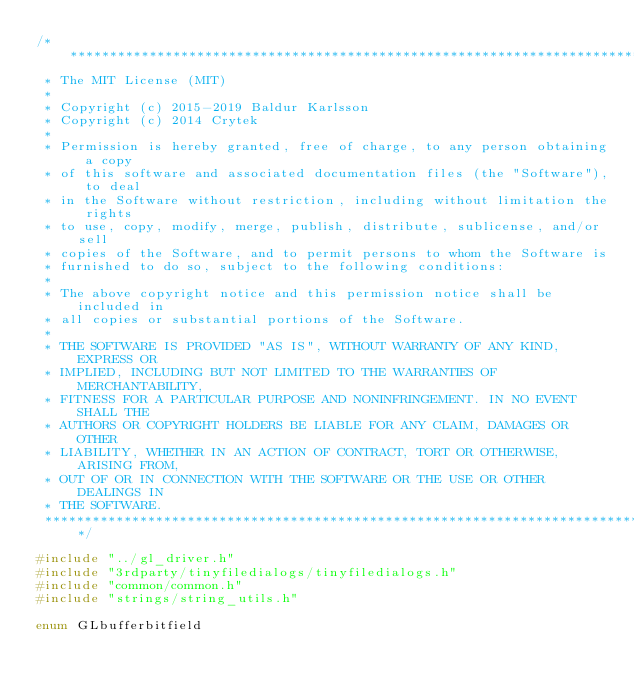Convert code to text. <code><loc_0><loc_0><loc_500><loc_500><_C++_>/******************************************************************************
 * The MIT License (MIT)
 *
 * Copyright (c) 2015-2019 Baldur Karlsson
 * Copyright (c) 2014 Crytek
 *
 * Permission is hereby granted, free of charge, to any person obtaining a copy
 * of this software and associated documentation files (the "Software"), to deal
 * in the Software without restriction, including without limitation the rights
 * to use, copy, modify, merge, publish, distribute, sublicense, and/or sell
 * copies of the Software, and to permit persons to whom the Software is
 * furnished to do so, subject to the following conditions:
 *
 * The above copyright notice and this permission notice shall be included in
 * all copies or substantial portions of the Software.
 *
 * THE SOFTWARE IS PROVIDED "AS IS", WITHOUT WARRANTY OF ANY KIND, EXPRESS OR
 * IMPLIED, INCLUDING BUT NOT LIMITED TO THE WARRANTIES OF MERCHANTABILITY,
 * FITNESS FOR A PARTICULAR PURPOSE AND NONINFRINGEMENT. IN NO EVENT SHALL THE
 * AUTHORS OR COPYRIGHT HOLDERS BE LIABLE FOR ANY CLAIM, DAMAGES OR OTHER
 * LIABILITY, WHETHER IN AN ACTION OF CONTRACT, TORT OR OTHERWISE, ARISING FROM,
 * OUT OF OR IN CONNECTION WITH THE SOFTWARE OR THE USE OR OTHER DEALINGS IN
 * THE SOFTWARE.
 ******************************************************************************/

#include "../gl_driver.h"
#include "3rdparty/tinyfiledialogs/tinyfiledialogs.h"
#include "common/common.h"
#include "strings/string_utils.h"

enum GLbufferbitfield</code> 